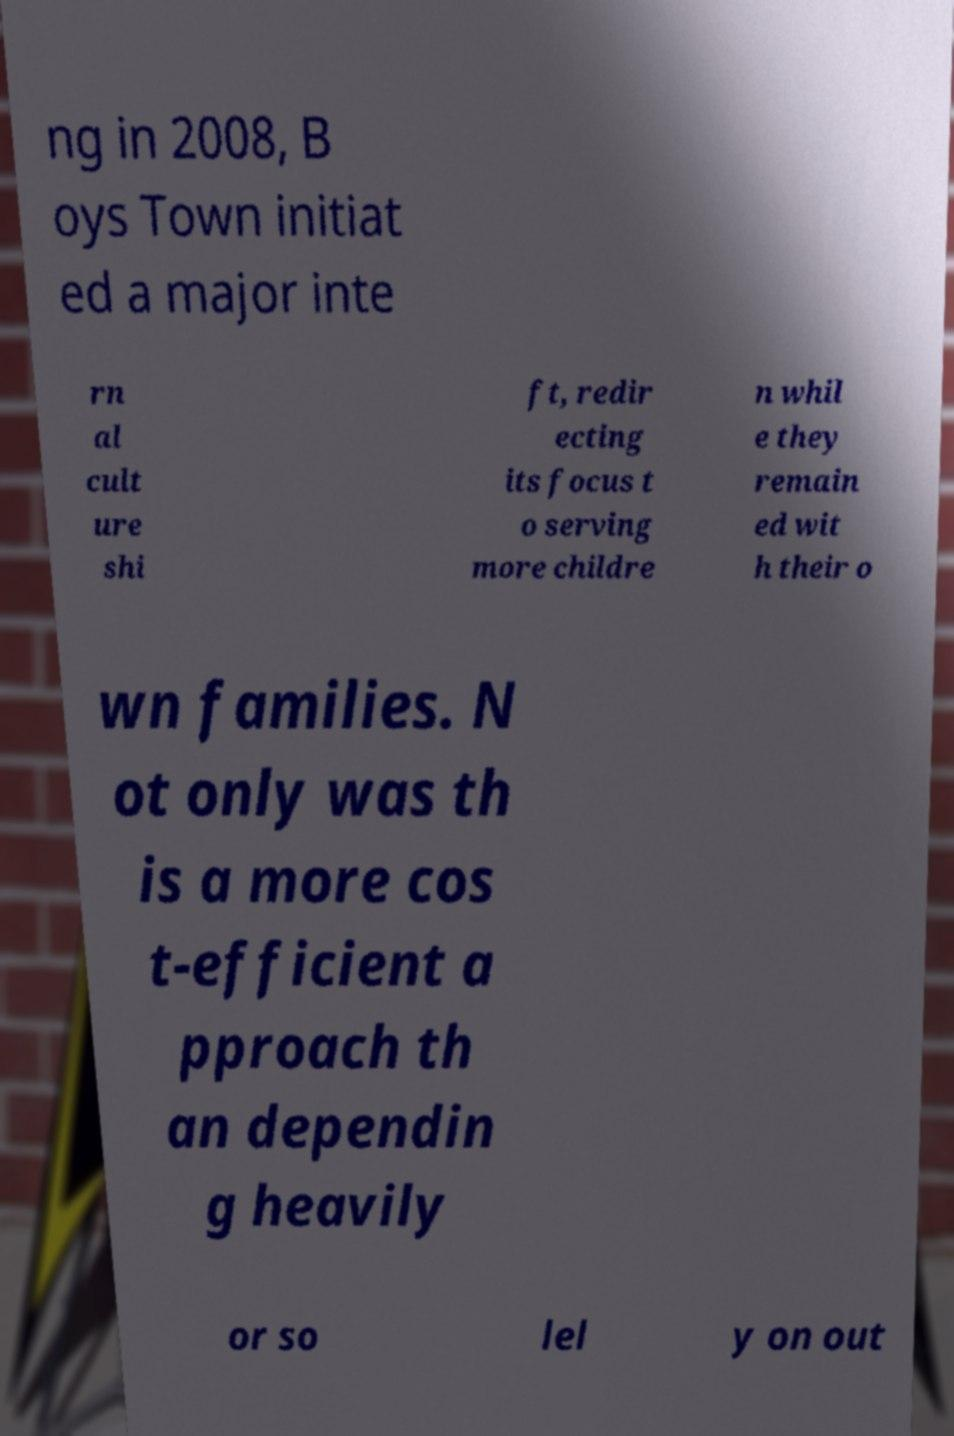There's text embedded in this image that I need extracted. Can you transcribe it verbatim? ng in 2008, B oys Town initiat ed a major inte rn al cult ure shi ft, redir ecting its focus t o serving more childre n whil e they remain ed wit h their o wn families. N ot only was th is a more cos t-efficient a pproach th an dependin g heavily or so lel y on out 